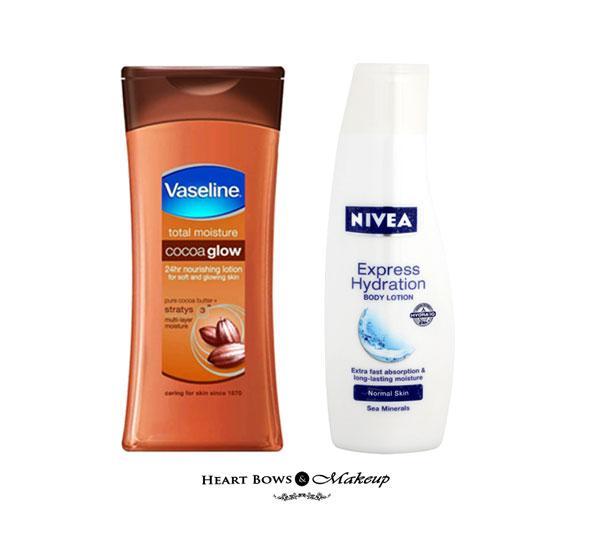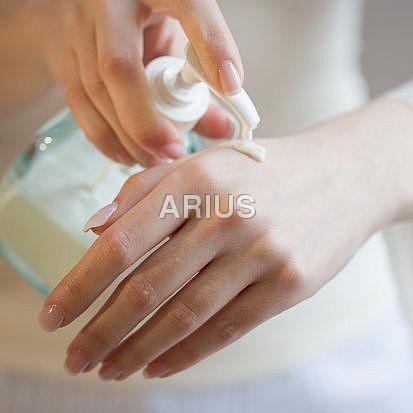The first image is the image on the left, the second image is the image on the right. Assess this claim about the two images: "In at least one of the image, lotion is being applied to a hand.". Correct or not? Answer yes or no. Yes. The first image is the image on the left, the second image is the image on the right. Assess this claim about the two images: "There are hands applying products in the images.". Correct or not? Answer yes or no. Yes. 